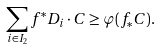Convert formula to latex. <formula><loc_0><loc_0><loc_500><loc_500>\sum _ { i \in I _ { 2 } } f ^ { * } D _ { i } \cdot C \geq \varphi ( f _ { * } C ) .</formula> 